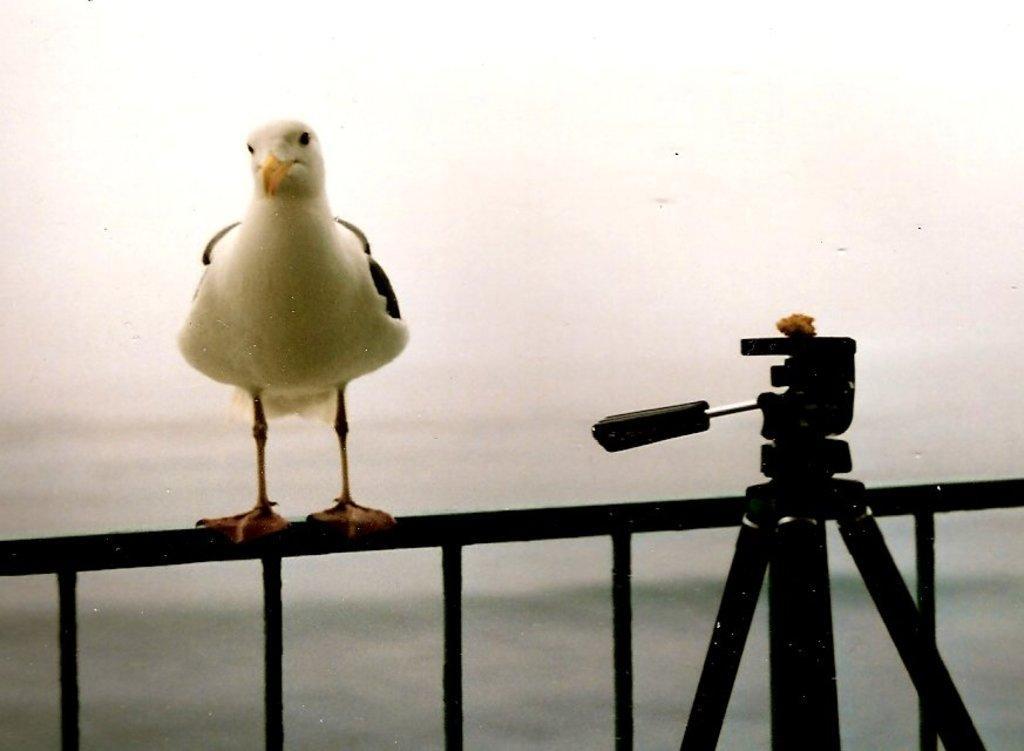Can you describe this image briefly? In this image, I can see a bird standing on iron grille and there is a tripod stand. The background is blurry. 